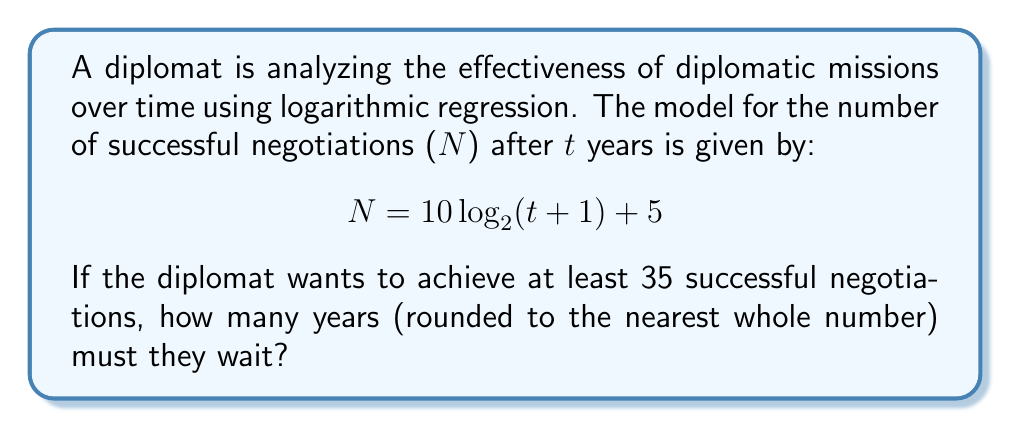Give your solution to this math problem. Let's approach this step-by-step:

1) We want to find t when N ≥ 35. So, let's set up the equation:
   
   $35 = 10 \log_{2}(t+1) + 5$

2) Subtract 5 from both sides:
   
   $30 = 10 \log_{2}(t+1)$

3) Divide both sides by 10:
   
   $3 = \log_{2}(t+1)$

4) Now, we need to solve for t. We can do this by applying $2^x$ to both sides:
   
   $2^3 = t+1$

5) Simplify the left side:
   
   $8 = t+1$

6) Subtract 1 from both sides to isolate t:
   
   $7 = t$

7) Therefore, the diplomat must wait 7 years to achieve at least 35 successful negotiations.

8) To verify:
   $N = 10 \log_{2}(7+1) + 5$
   $= 10 \log_{2}(8) + 5$
   $= 10 * 3 + 5$
   $= 35$

This confirms our calculation.
Answer: 7 years 